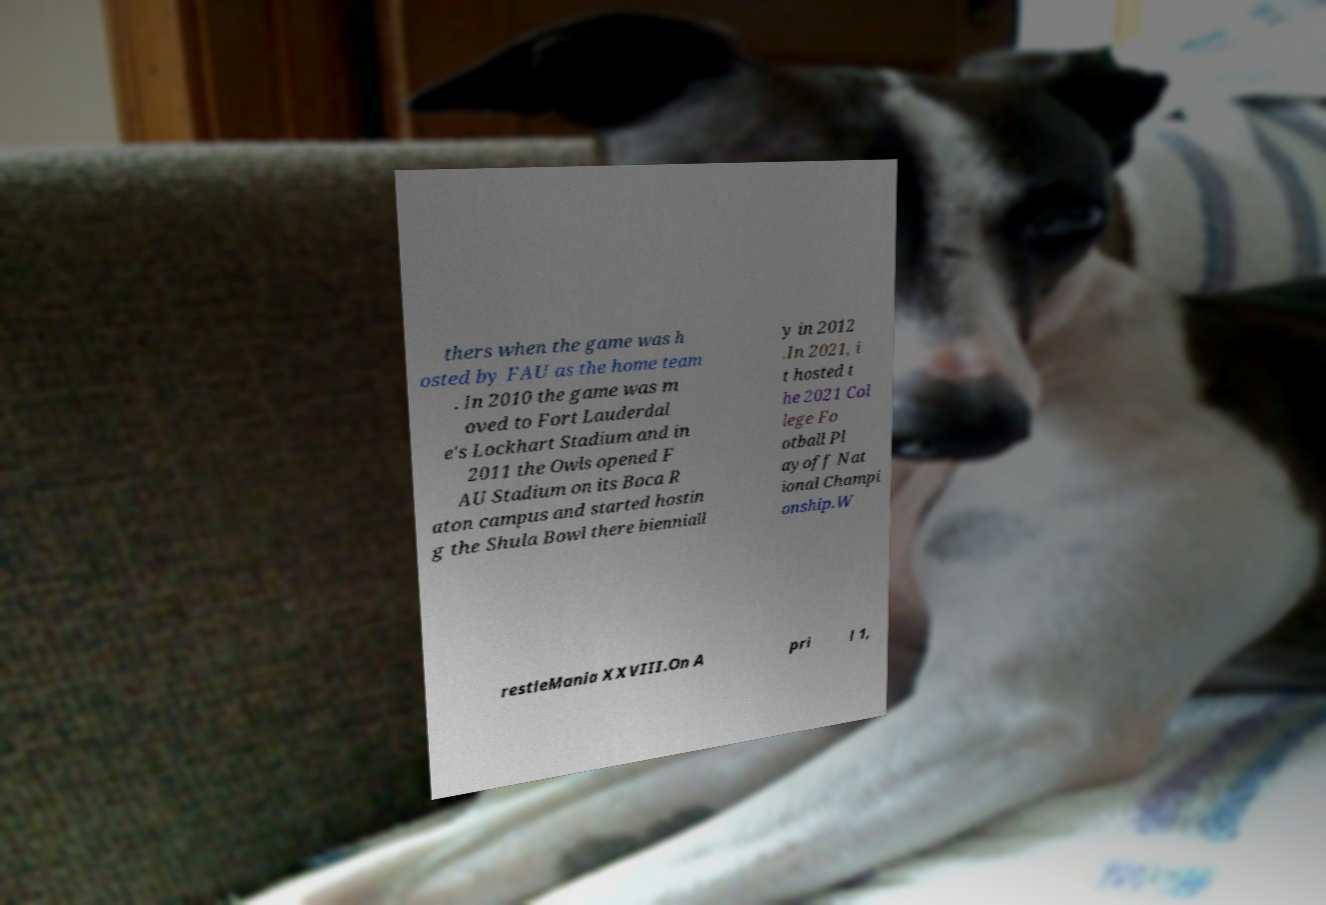There's text embedded in this image that I need extracted. Can you transcribe it verbatim? thers when the game was h osted by FAU as the home team . In 2010 the game was m oved to Fort Lauderdal e's Lockhart Stadium and in 2011 the Owls opened F AU Stadium on its Boca R aton campus and started hostin g the Shula Bowl there bienniall y in 2012 .In 2021, i t hosted t he 2021 Col lege Fo otball Pl ayoff Nat ional Champi onship.W restleMania XXVIII.On A pri l 1, 